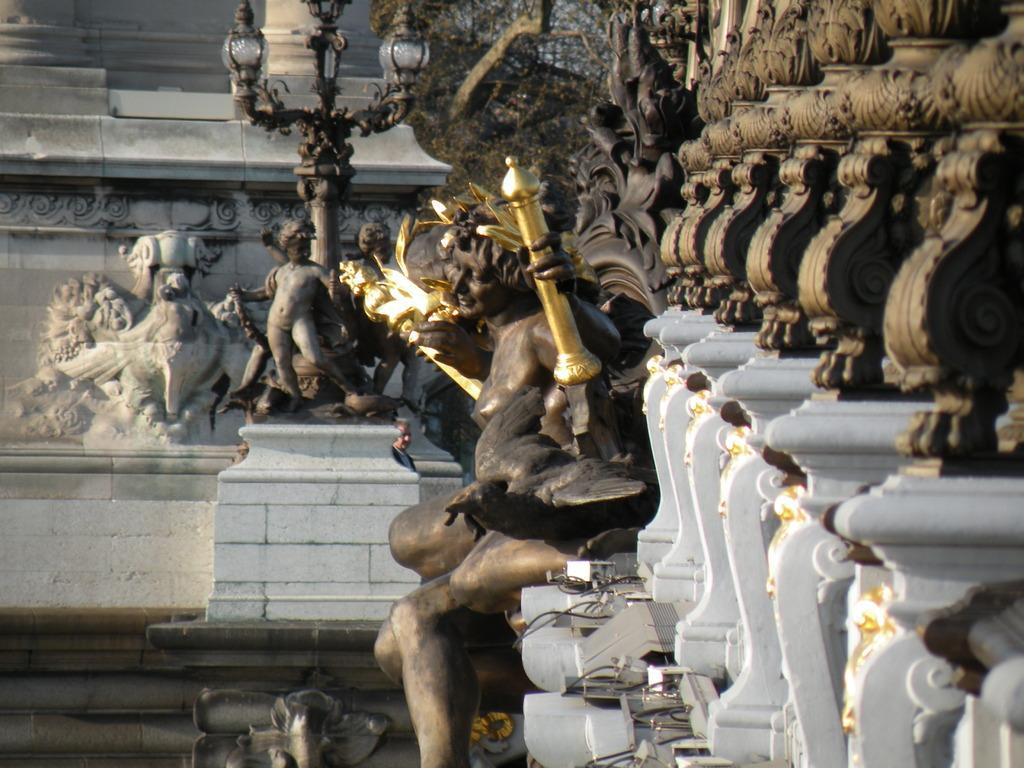Can you describe this image briefly? In the image in the center, we can see sculptures, fences and a few other objects. In the background there is a wall etc. 